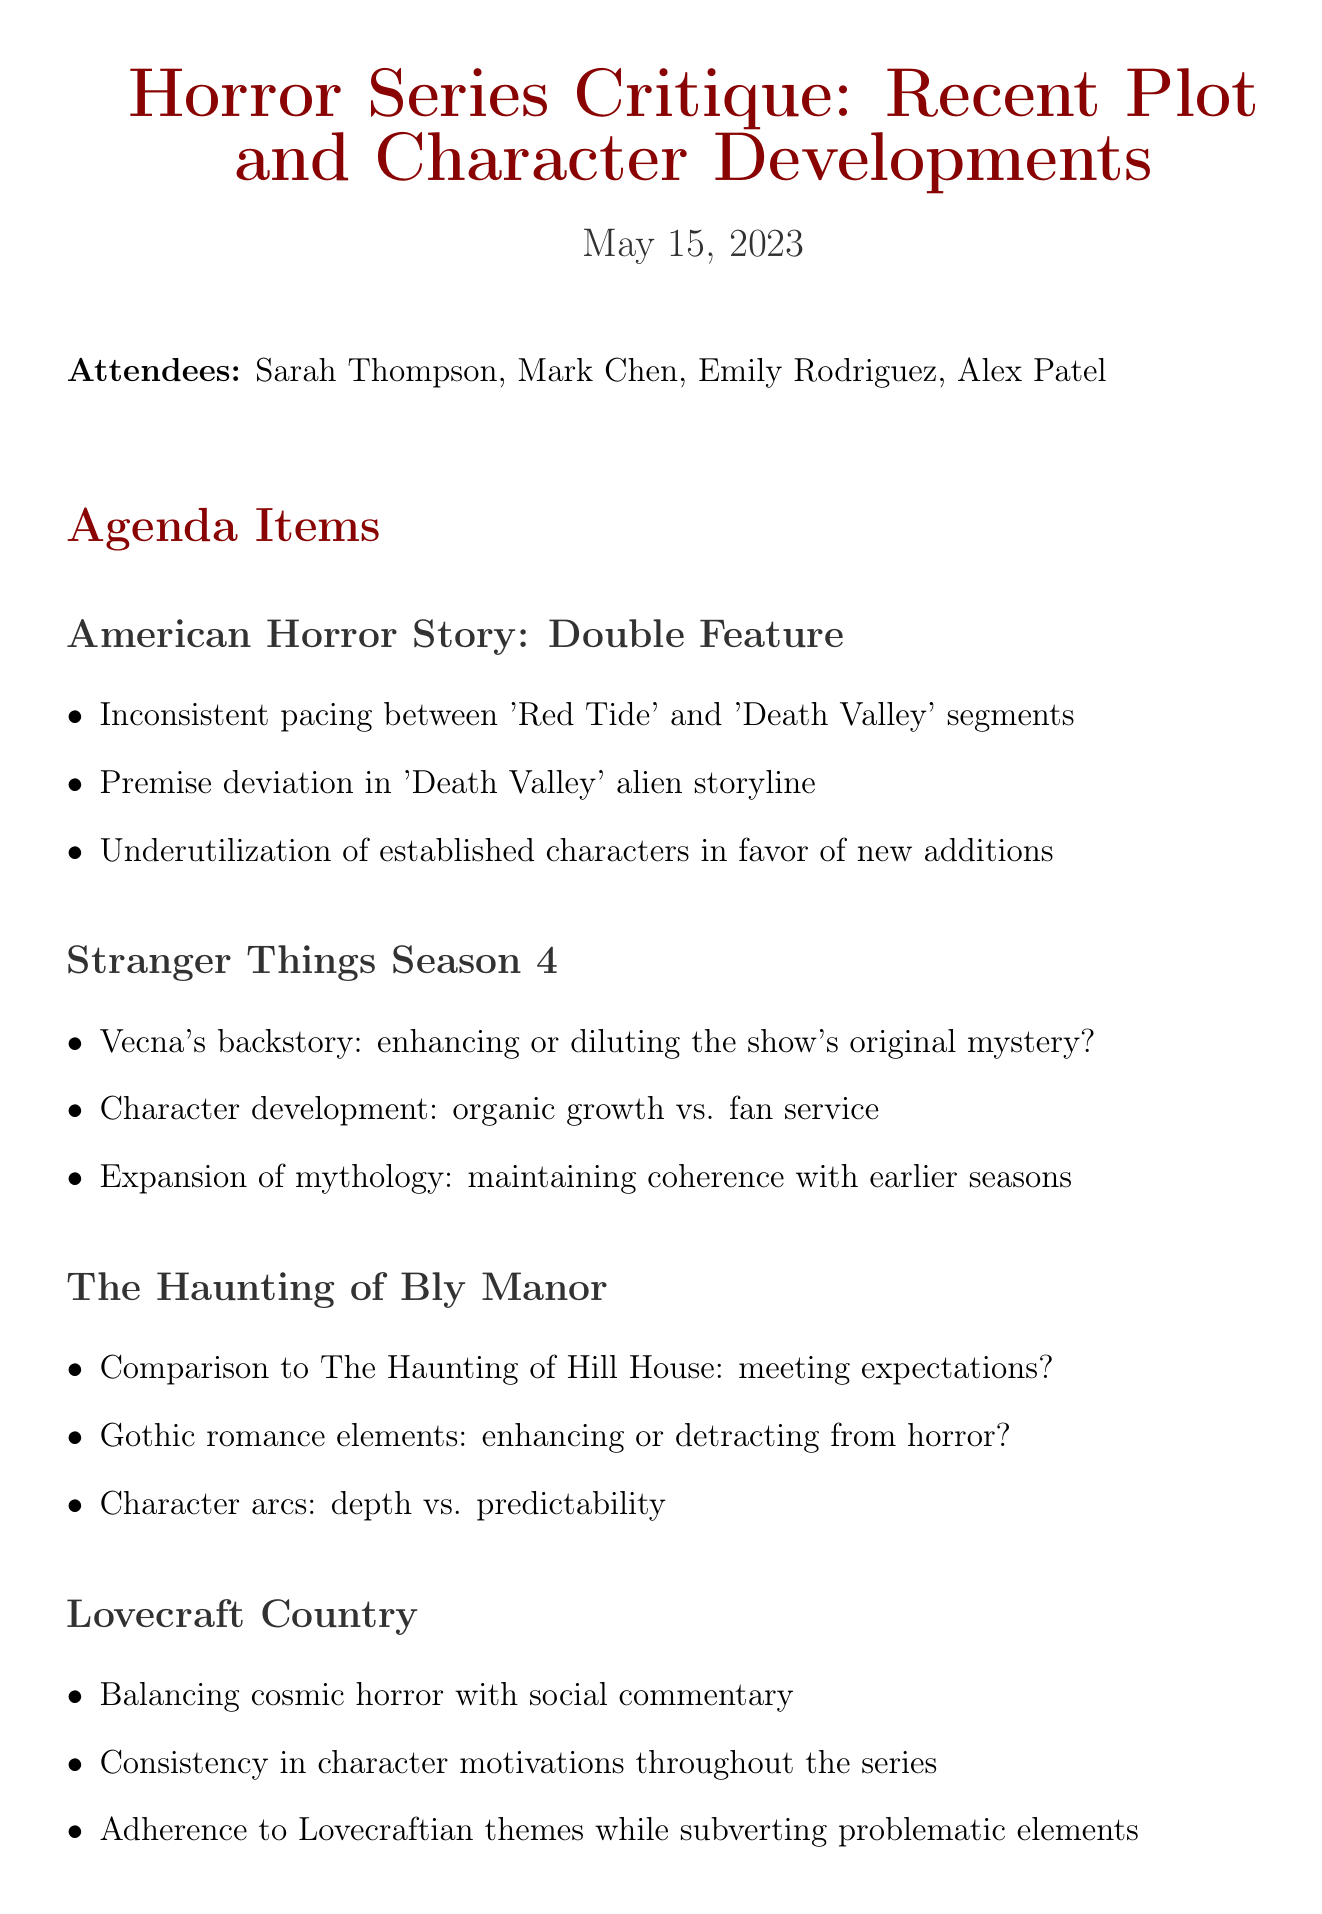What is the meeting title? The meeting title is the main focus of the document and is clearly stated at the beginning.
Answer: Horror Series Critique: Recent Plot and Character Developments What is the date of the meeting? The date of the meeting is specified in the introductory section of the document.
Answer: May 15, 2023 Who are the attendees? The names of the attendees are listed as participants in the meeting at the start of the document.
Answer: Sarah Thompson, Mark Chen, Emily Rodriguez, Alex Patel Which series had inconsistent pacing mentioned in the critique? The agenda items detail specific series discussed during the meeting, including issues such as inconsistent pacing.
Answer: American Horror Story: Double Feature What action item involves audience reactions? Action items are outlined at the end of the document, detailing the tasks to be completed post-meeting.
Answer: Analyze audience reactions to plot twists in recent horror shows What does the critique suggest about Vecna's backstory in Stranger Things? The points under each series discuss various aspects of the series, including character arcs and backstories.
Answer: Enhancing or diluting the show's original mystery How many agenda items are listed in total? Each section of the document presents a distinct series for critique, contributing to the overall number of agenda items.
Answer: Four What is the next meeting date? The next meeting date is mentioned at the end of the document, highlighting continuity in discussions.
Answer: June 12, 2023 What theme is Lovecraft Country noted for balancing? The agenda points for Lovecraft Country mention themes that reflect its narrative focus.
Answer: Cosmic horror with social commentary 